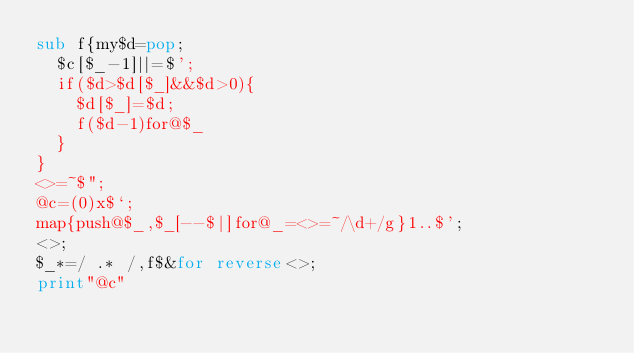Convert code to text. <code><loc_0><loc_0><loc_500><loc_500><_Perl_>sub f{my$d=pop;
	$c[$_-1]||=$';
	if($d>$d[$_]&&$d>0){
		$d[$_]=$d;
		f($d-1)for@$_
	}
}
<>=~$";
@c=(0)x$`;
map{push@$_,$_[--$|]for@_=<>=~/\d+/g}1..$';
<>;
$_*=/ .* /,f$&for reverse<>;
print"@c"
</code> 